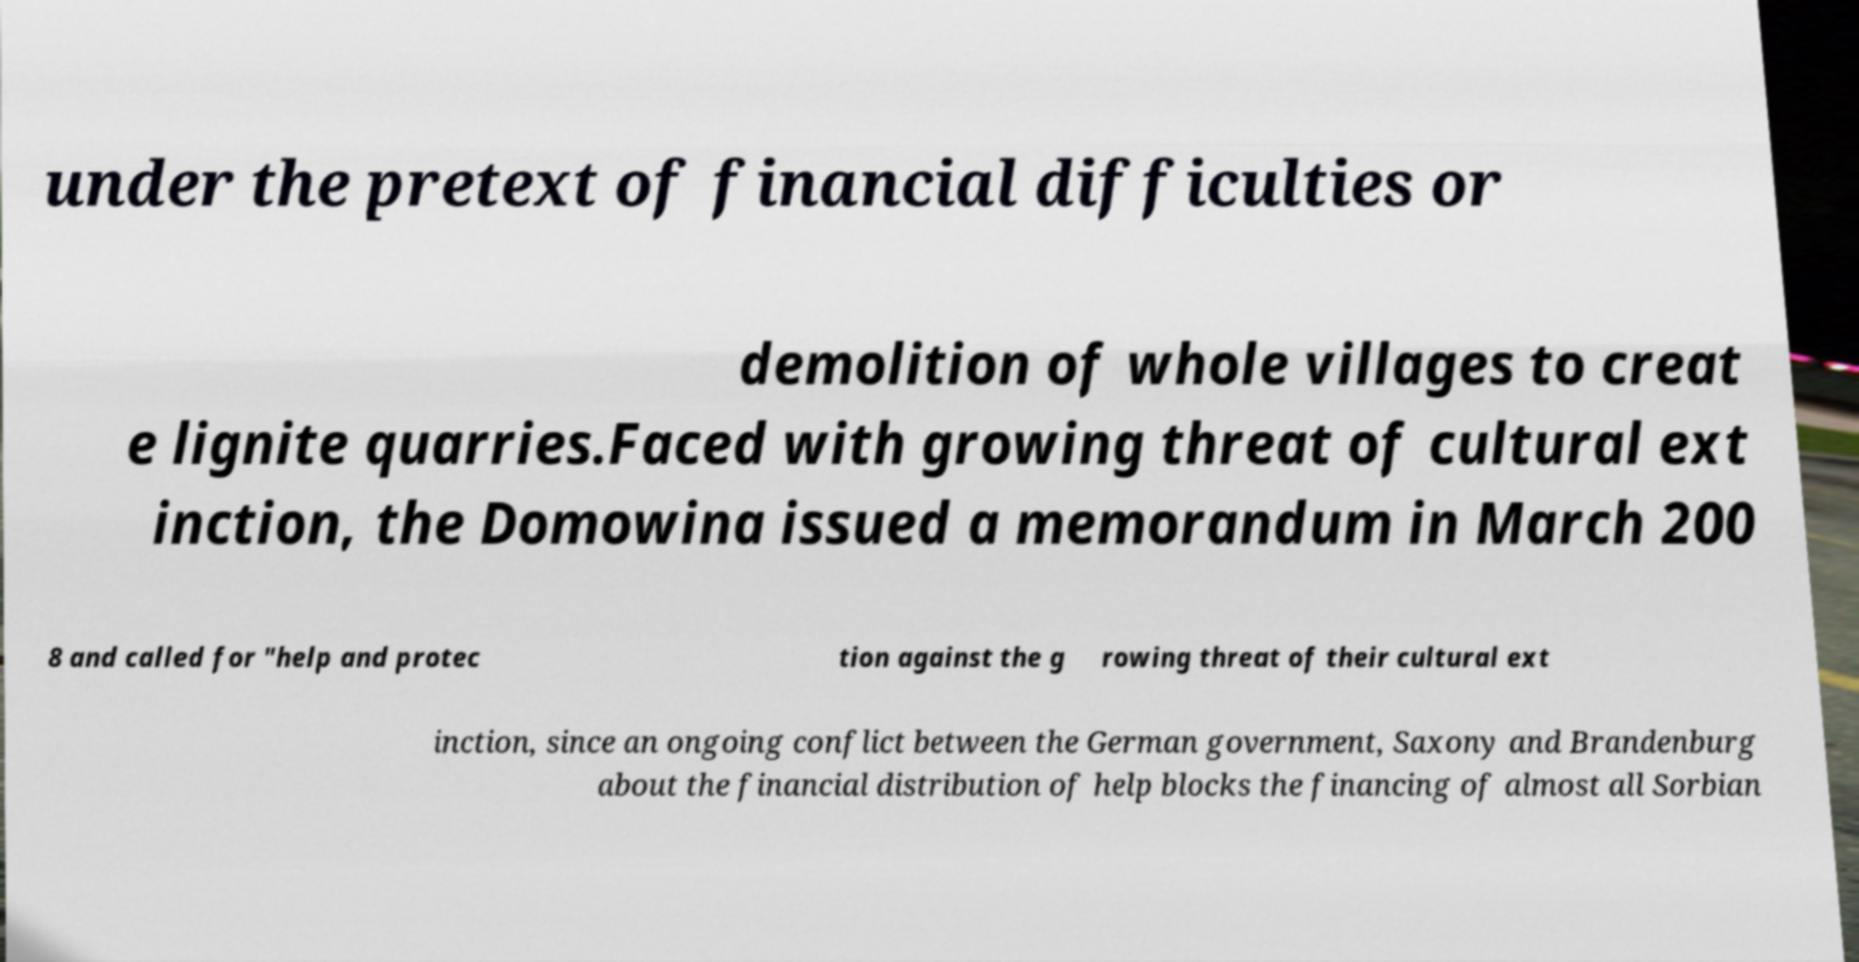Please read and relay the text visible in this image. What does it say? under the pretext of financial difficulties or demolition of whole villages to creat e lignite quarries.Faced with growing threat of cultural ext inction, the Domowina issued a memorandum in March 200 8 and called for "help and protec tion against the g rowing threat of their cultural ext inction, since an ongoing conflict between the German government, Saxony and Brandenburg about the financial distribution of help blocks the financing of almost all Sorbian 